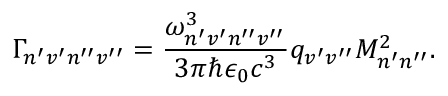<formula> <loc_0><loc_0><loc_500><loc_500>\Gamma _ { n ^ { \prime } v ^ { \prime } n ^ { \prime \prime } v ^ { \prime \prime } } = \frac { \omega _ { n ^ { \prime } v ^ { \prime } n ^ { \prime \prime } v ^ { \prime \prime } } ^ { 3 } } { 3 \pi \hbar { \epsilon } _ { 0 } c ^ { 3 } } q _ { v ^ { \prime } v ^ { \prime \prime } } M _ { n ^ { \prime } n ^ { \prime \prime } } ^ { 2 } .</formula> 